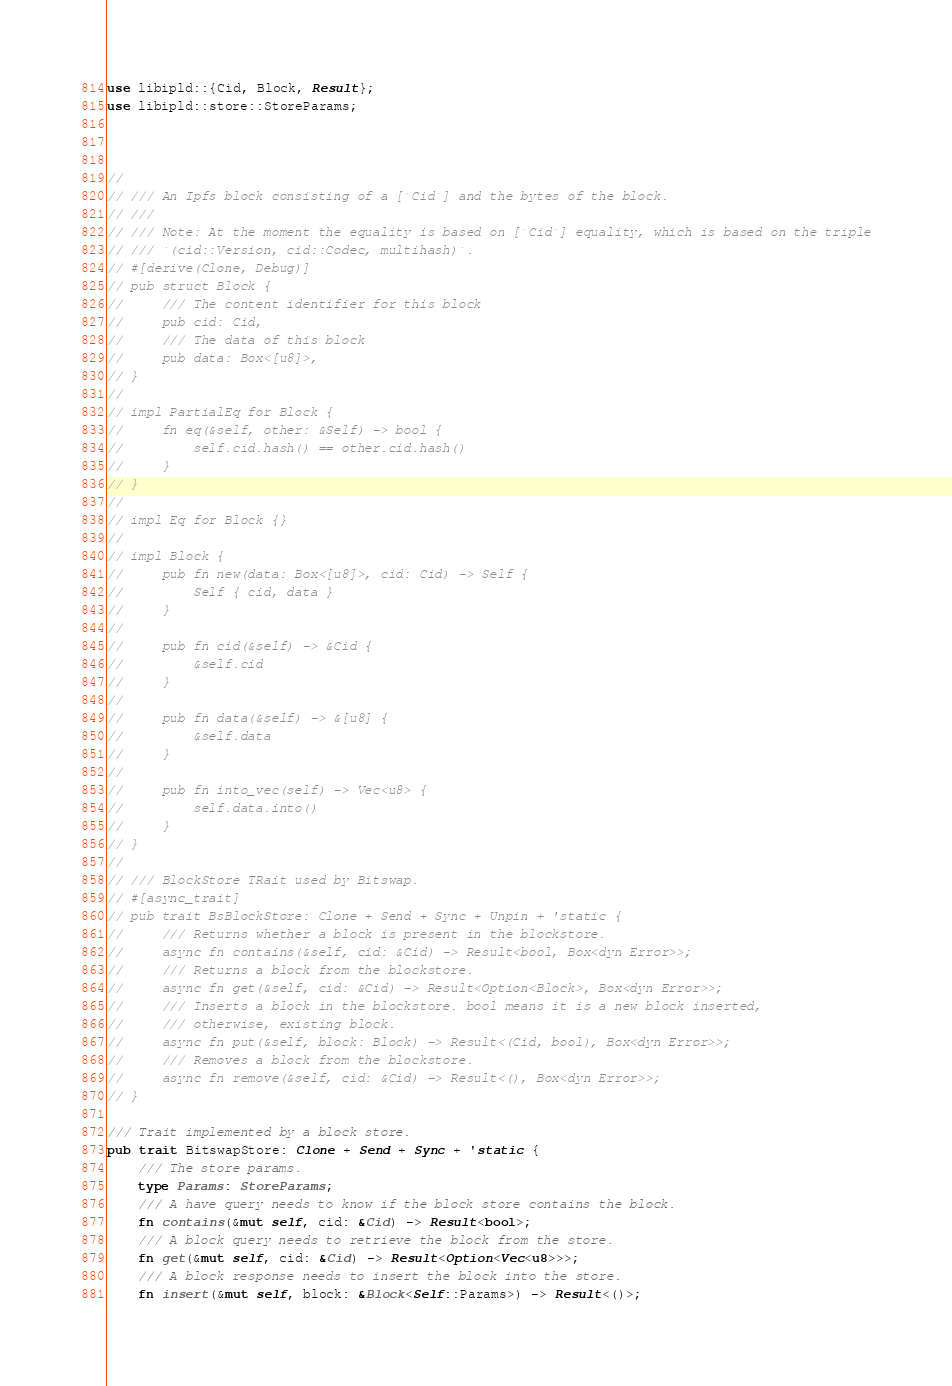Convert code to text. <code><loc_0><loc_0><loc_500><loc_500><_Rust_>
use libipld::{Cid, Block, Result};
use libipld::store::StoreParams;



//
// /// An Ipfs block consisting of a [`Cid`] and the bytes of the block.
// ///
// /// Note: At the moment the equality is based on [`Cid`] equality, which is based on the triple
// /// `(cid::Version, cid::Codec, multihash)`.
// #[derive(Clone, Debug)]
// pub struct Block {
//     /// The content identifier for this block
//     pub cid: Cid,
//     /// The data of this block
//     pub data: Box<[u8]>,
// }
//
// impl PartialEq for Block {
//     fn eq(&self, other: &Self) -> bool {
//         self.cid.hash() == other.cid.hash()
//     }
// }
//
// impl Eq for Block {}
//
// impl Block {
//     pub fn new(data: Box<[u8]>, cid: Cid) -> Self {
//         Self { cid, data }
//     }
//
//     pub fn cid(&self) -> &Cid {
//         &self.cid
//     }
//
//     pub fn data(&self) -> &[u8] {
//         &self.data
//     }
//
//     pub fn into_vec(self) -> Vec<u8> {
//         self.data.into()
//     }
// }
//
// /// BlockStore TRait used by Bitswap.
// #[async_trait]
// pub trait BsBlockStore: Clone + Send + Sync + Unpin + 'static {
//     /// Returns whether a block is present in the blockstore.
//     async fn contains(&self, cid: &Cid) -> Result<bool, Box<dyn Error>>;
//     /// Returns a block from the blockstore.
//     async fn get(&self, cid: &Cid) -> Result<Option<Block>, Box<dyn Error>>;
//     /// Inserts a block in the blockstore. bool means it is a new block inserted,
//     /// otherwise, existing block.
//     async fn put(&self, block: Block) -> Result<(Cid, bool), Box<dyn Error>>;
//     /// Removes a block from the blockstore.
//     async fn remove(&self, cid: &Cid) -> Result<(), Box<dyn Error>>;
// }

/// Trait implemented by a block store.
pub trait BitswapStore: Clone + Send + Sync + 'static {
    /// The store params.
    type Params: StoreParams;
    /// A have query needs to know if the block store contains the block.
    fn contains(&mut self, cid: &Cid) -> Result<bool>;
    /// A block query needs to retrieve the block from the store.
    fn get(&mut self, cid: &Cid) -> Result<Option<Vec<u8>>>;
    /// A block response needs to insert the block into the store.
    fn insert(&mut self, block: &Block<Self::Params>) -> Result<()>;</code> 